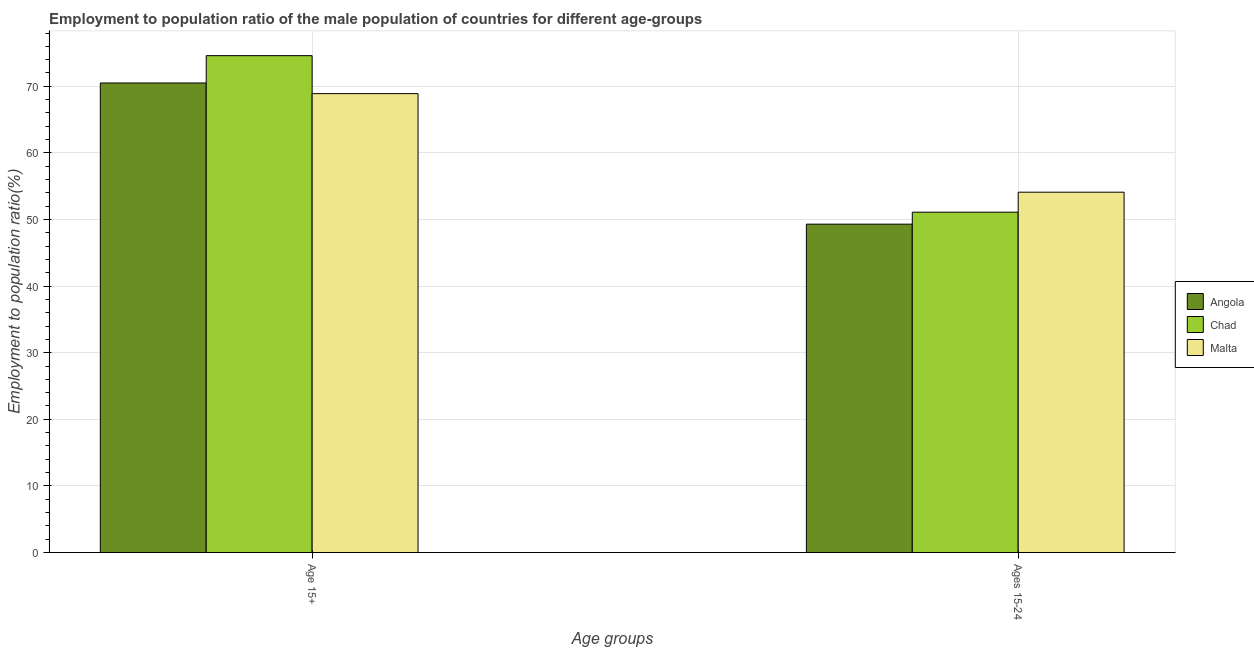How many groups of bars are there?
Ensure brevity in your answer.  2. Are the number of bars per tick equal to the number of legend labels?
Ensure brevity in your answer.  Yes. Are the number of bars on each tick of the X-axis equal?
Offer a terse response. Yes. What is the label of the 2nd group of bars from the left?
Your answer should be very brief. Ages 15-24. What is the employment to population ratio(age 15-24) in Malta?
Give a very brief answer. 54.1. Across all countries, what is the maximum employment to population ratio(age 15-24)?
Your answer should be very brief. 54.1. Across all countries, what is the minimum employment to population ratio(age 15-24)?
Keep it short and to the point. 49.3. In which country was the employment to population ratio(age 15+) maximum?
Make the answer very short. Chad. In which country was the employment to population ratio(age 15-24) minimum?
Provide a succinct answer. Angola. What is the total employment to population ratio(age 15-24) in the graph?
Provide a short and direct response. 154.5. What is the difference between the employment to population ratio(age 15+) in Angola and that in Malta?
Offer a terse response. 1.6. What is the difference between the employment to population ratio(age 15-24) in Angola and the employment to population ratio(age 15+) in Malta?
Offer a terse response. -19.6. What is the average employment to population ratio(age 15-24) per country?
Your answer should be very brief. 51.5. What is the difference between the employment to population ratio(age 15+) and employment to population ratio(age 15-24) in Angola?
Provide a succinct answer. 21.2. In how many countries, is the employment to population ratio(age 15+) greater than 52 %?
Your response must be concise. 3. What is the ratio of the employment to population ratio(age 15+) in Malta to that in Chad?
Keep it short and to the point. 0.92. Is the employment to population ratio(age 15+) in Chad less than that in Angola?
Your answer should be compact. No. In how many countries, is the employment to population ratio(age 15+) greater than the average employment to population ratio(age 15+) taken over all countries?
Ensure brevity in your answer.  1. What does the 2nd bar from the left in Age 15+ represents?
Give a very brief answer. Chad. What does the 3rd bar from the right in Ages 15-24 represents?
Ensure brevity in your answer.  Angola. Are all the bars in the graph horizontal?
Your answer should be compact. No. What is the difference between two consecutive major ticks on the Y-axis?
Provide a short and direct response. 10. Where does the legend appear in the graph?
Make the answer very short. Center right. What is the title of the graph?
Your answer should be very brief. Employment to population ratio of the male population of countries for different age-groups. Does "Thailand" appear as one of the legend labels in the graph?
Offer a very short reply. No. What is the label or title of the X-axis?
Your response must be concise. Age groups. What is the Employment to population ratio(%) in Angola in Age 15+?
Offer a very short reply. 70.5. What is the Employment to population ratio(%) in Chad in Age 15+?
Your answer should be compact. 74.6. What is the Employment to population ratio(%) of Malta in Age 15+?
Keep it short and to the point. 68.9. What is the Employment to population ratio(%) in Angola in Ages 15-24?
Your answer should be compact. 49.3. What is the Employment to population ratio(%) of Chad in Ages 15-24?
Offer a terse response. 51.1. What is the Employment to population ratio(%) of Malta in Ages 15-24?
Give a very brief answer. 54.1. Across all Age groups, what is the maximum Employment to population ratio(%) of Angola?
Your answer should be compact. 70.5. Across all Age groups, what is the maximum Employment to population ratio(%) of Chad?
Keep it short and to the point. 74.6. Across all Age groups, what is the maximum Employment to population ratio(%) in Malta?
Provide a succinct answer. 68.9. Across all Age groups, what is the minimum Employment to population ratio(%) in Angola?
Offer a terse response. 49.3. Across all Age groups, what is the minimum Employment to population ratio(%) in Chad?
Keep it short and to the point. 51.1. Across all Age groups, what is the minimum Employment to population ratio(%) in Malta?
Provide a short and direct response. 54.1. What is the total Employment to population ratio(%) of Angola in the graph?
Ensure brevity in your answer.  119.8. What is the total Employment to population ratio(%) in Chad in the graph?
Make the answer very short. 125.7. What is the total Employment to population ratio(%) in Malta in the graph?
Give a very brief answer. 123. What is the difference between the Employment to population ratio(%) in Angola in Age 15+ and that in Ages 15-24?
Ensure brevity in your answer.  21.2. What is the difference between the Employment to population ratio(%) in Chad in Age 15+ and the Employment to population ratio(%) in Malta in Ages 15-24?
Provide a short and direct response. 20.5. What is the average Employment to population ratio(%) in Angola per Age groups?
Give a very brief answer. 59.9. What is the average Employment to population ratio(%) in Chad per Age groups?
Your answer should be very brief. 62.85. What is the average Employment to population ratio(%) of Malta per Age groups?
Offer a very short reply. 61.5. What is the difference between the Employment to population ratio(%) of Angola and Employment to population ratio(%) of Chad in Age 15+?
Provide a short and direct response. -4.1. What is the difference between the Employment to population ratio(%) of Angola and Employment to population ratio(%) of Malta in Age 15+?
Provide a short and direct response. 1.6. What is the difference between the Employment to population ratio(%) of Chad and Employment to population ratio(%) of Malta in Age 15+?
Offer a terse response. 5.7. What is the difference between the Employment to population ratio(%) in Chad and Employment to population ratio(%) in Malta in Ages 15-24?
Your answer should be compact. -3. What is the ratio of the Employment to population ratio(%) of Angola in Age 15+ to that in Ages 15-24?
Make the answer very short. 1.43. What is the ratio of the Employment to population ratio(%) of Chad in Age 15+ to that in Ages 15-24?
Keep it short and to the point. 1.46. What is the ratio of the Employment to population ratio(%) in Malta in Age 15+ to that in Ages 15-24?
Ensure brevity in your answer.  1.27. What is the difference between the highest and the second highest Employment to population ratio(%) of Angola?
Offer a terse response. 21.2. What is the difference between the highest and the second highest Employment to population ratio(%) in Chad?
Offer a very short reply. 23.5. What is the difference between the highest and the second highest Employment to population ratio(%) in Malta?
Make the answer very short. 14.8. What is the difference between the highest and the lowest Employment to population ratio(%) in Angola?
Offer a very short reply. 21.2. What is the difference between the highest and the lowest Employment to population ratio(%) of Chad?
Provide a succinct answer. 23.5. What is the difference between the highest and the lowest Employment to population ratio(%) of Malta?
Keep it short and to the point. 14.8. 